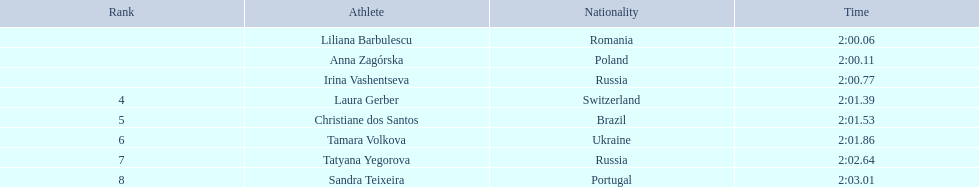Which female athletes took part in the 2003 summer universiade - women's 800 meters? Liliana Barbulescu, Anna Zagórska, Irina Vashentseva, Laura Gerber, Christiane dos Santos, Tamara Volkova, Tatyana Yegorova, Sandra Teixeira. Out of them, who are polish? Anna Zagórska. What is her duration? 2:00.11. 